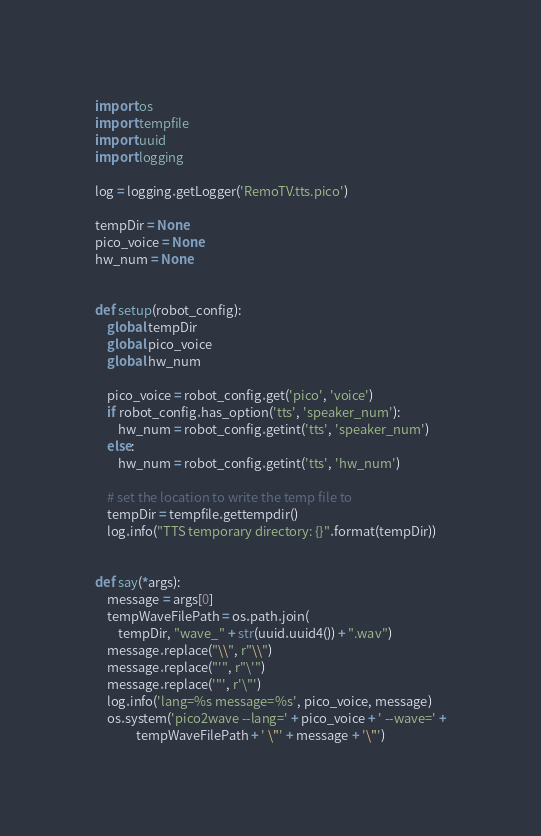<code> <loc_0><loc_0><loc_500><loc_500><_Python_>import os
import tempfile
import uuid
import logging

log = logging.getLogger('RemoTV.tts.pico')

tempDir = None
pico_voice = None
hw_num = None


def setup(robot_config):
    global tempDir
    global pico_voice
    global hw_num

    pico_voice = robot_config.get('pico', 'voice')
    if robot_config.has_option('tts', 'speaker_num'):
        hw_num = robot_config.getint('tts', 'speaker_num')
    else:
        hw_num = robot_config.getint('tts', 'hw_num')

    # set the location to write the temp file to
    tempDir = tempfile.gettempdir()
    log.info("TTS temporary directory: {}".format(tempDir))


def say(*args):
    message = args[0]
    tempWaveFilePath = os.path.join(
        tempDir, "wave_" + str(uuid.uuid4()) + ".wav")
    message.replace("\\", r"\\")
    message.replace("'", r"\'")
    message.replace('"', r'\"')
    log.info('lang=%s message=%s', pico_voice, message)
    os.system('pico2wave --lang=' + pico_voice + ' --wave=' +
              tempWaveFilePath + ' \"' + message + '\"')</code> 